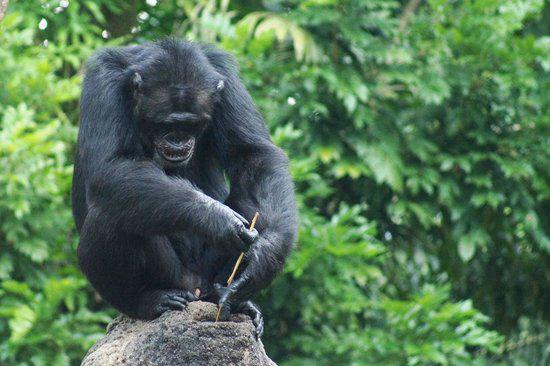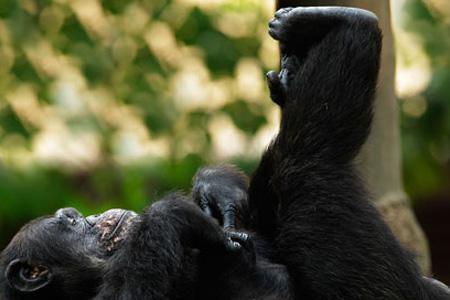The first image is the image on the left, the second image is the image on the right. Given the left and right images, does the statement "A baby ape is riding it's mothers back." hold true? Answer yes or no. No. 